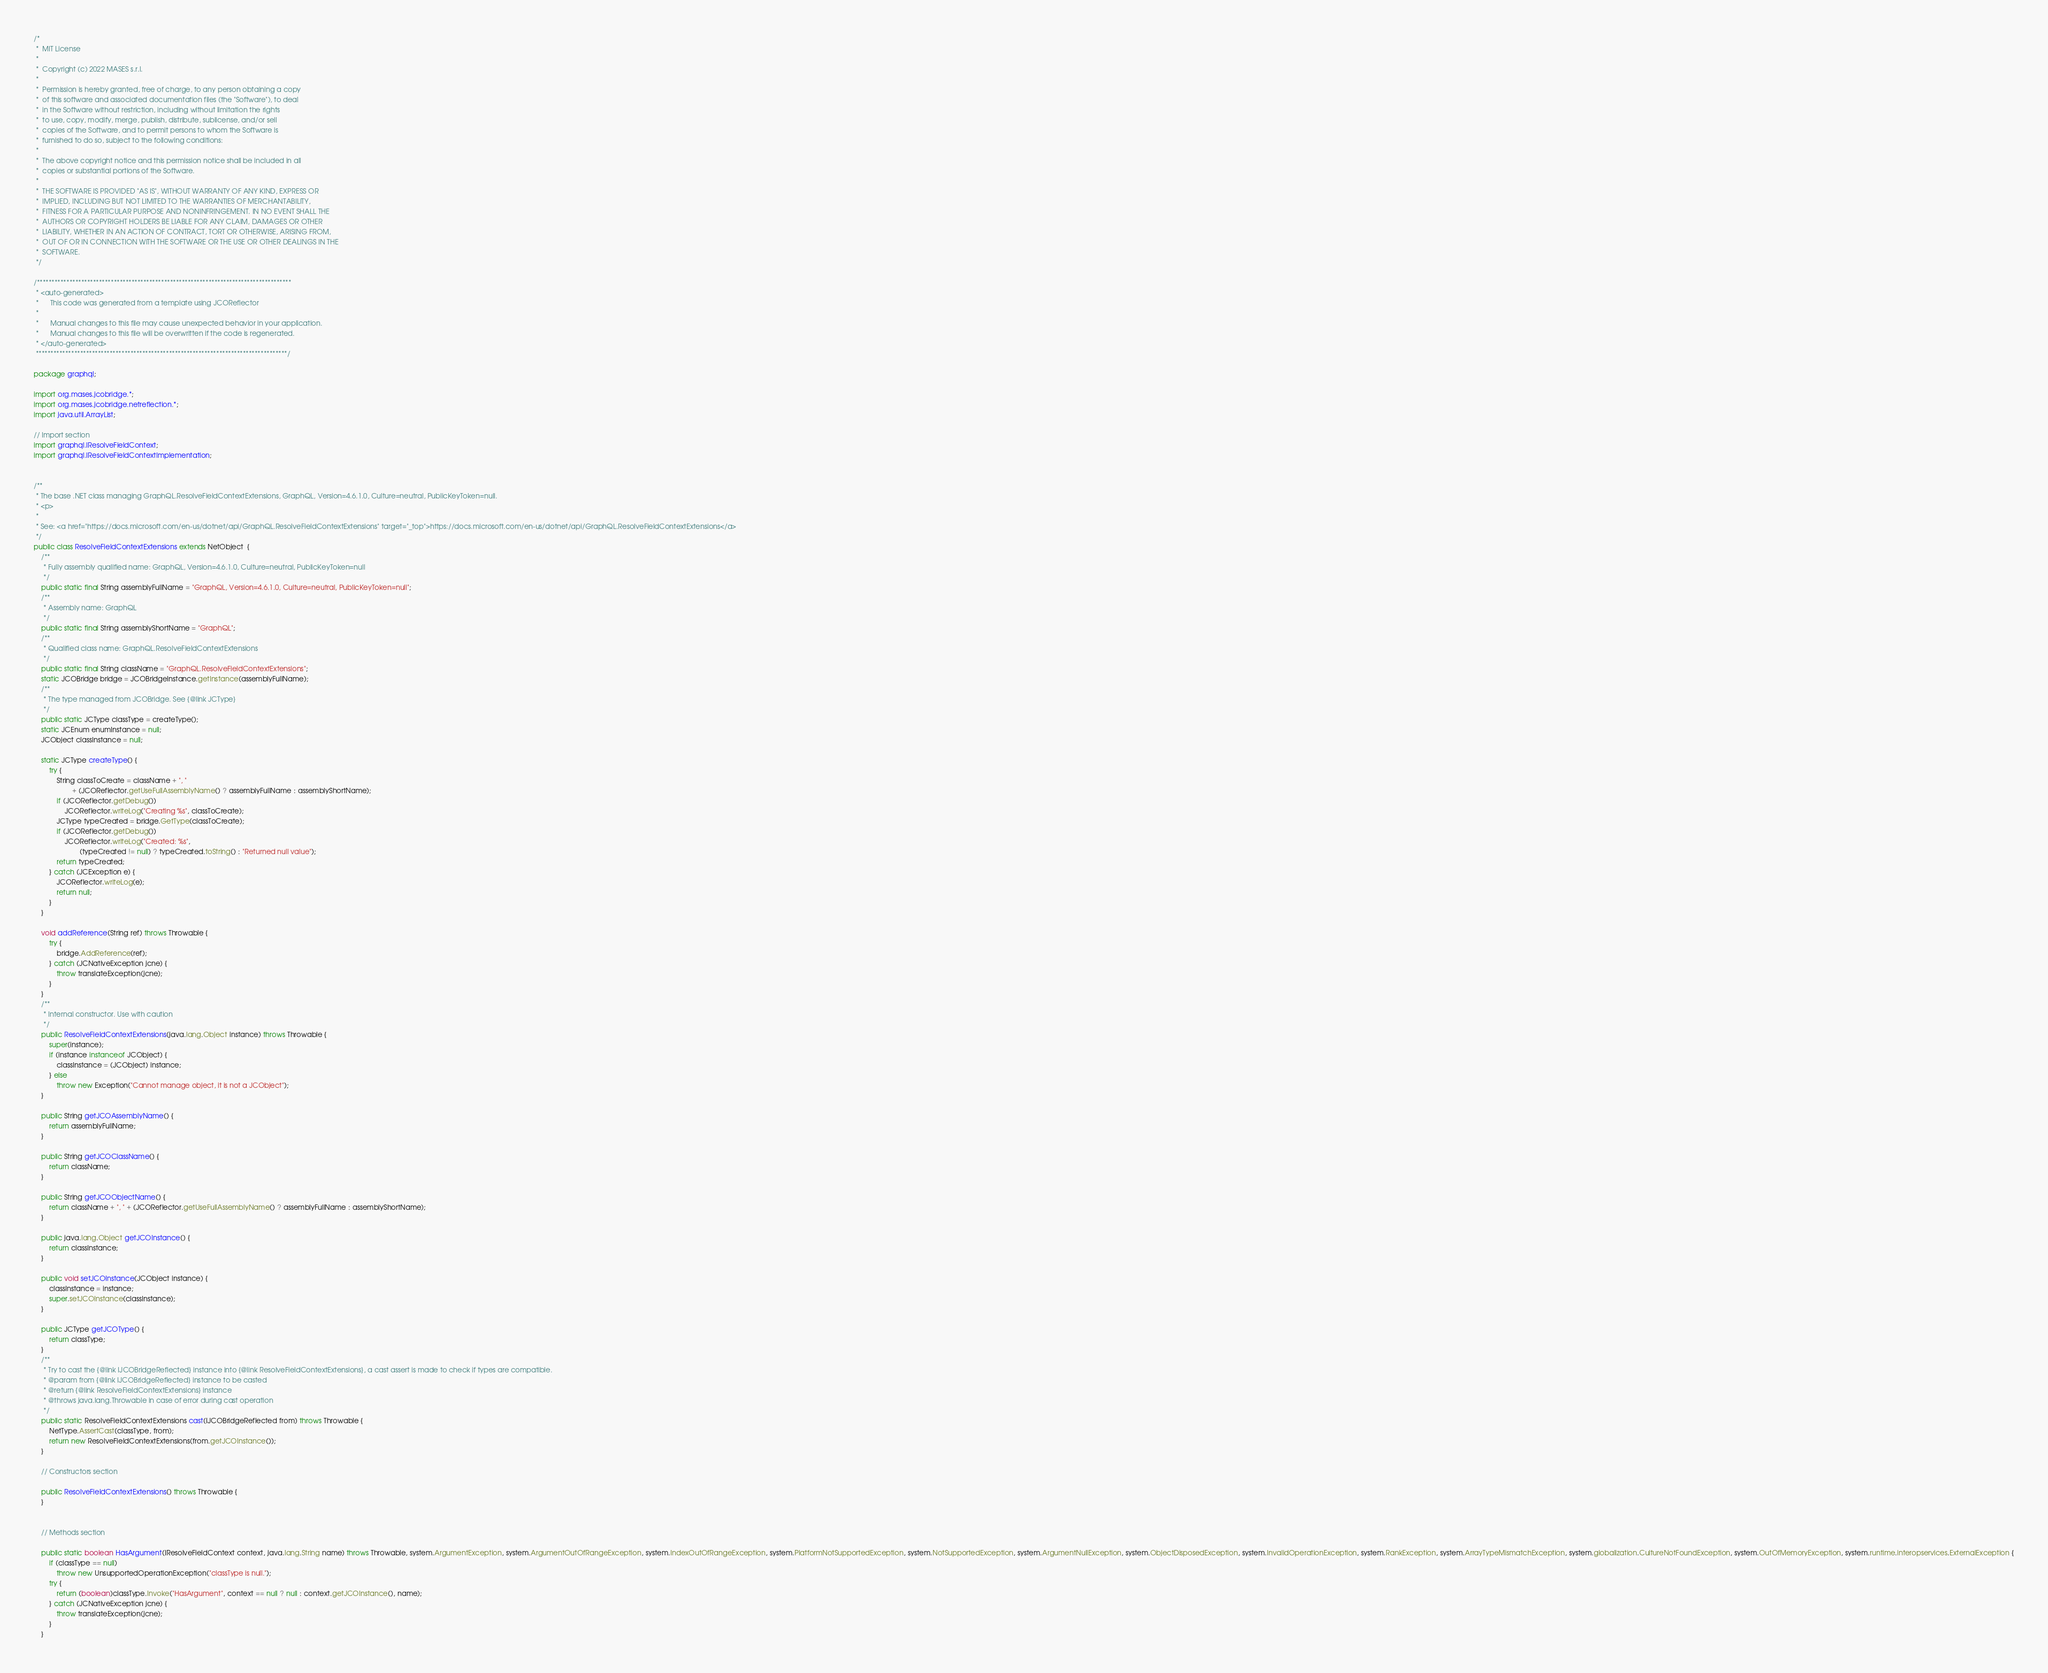Convert code to text. <code><loc_0><loc_0><loc_500><loc_500><_Java_>/*
 *  MIT License
 *
 *  Copyright (c) 2022 MASES s.r.l.
 *
 *  Permission is hereby granted, free of charge, to any person obtaining a copy
 *  of this software and associated documentation files (the "Software"), to deal
 *  in the Software without restriction, including without limitation the rights
 *  to use, copy, modify, merge, publish, distribute, sublicense, and/or sell
 *  copies of the Software, and to permit persons to whom the Software is
 *  furnished to do so, subject to the following conditions:
 *
 *  The above copyright notice and this permission notice shall be included in all
 *  copies or substantial portions of the Software.
 *
 *  THE SOFTWARE IS PROVIDED "AS IS", WITHOUT WARRANTY OF ANY KIND, EXPRESS OR
 *  IMPLIED, INCLUDING BUT NOT LIMITED TO THE WARRANTIES OF MERCHANTABILITY,
 *  FITNESS FOR A PARTICULAR PURPOSE AND NONINFRINGEMENT. IN NO EVENT SHALL THE
 *  AUTHORS OR COPYRIGHT HOLDERS BE LIABLE FOR ANY CLAIM, DAMAGES OR OTHER
 *  LIABILITY, WHETHER IN AN ACTION OF CONTRACT, TORT OR OTHERWISE, ARISING FROM,
 *  OUT OF OR IN CONNECTION WITH THE SOFTWARE OR THE USE OR OTHER DEALINGS IN THE
 *  SOFTWARE.
 */

/**************************************************************************************
 * <auto-generated>
 *      This code was generated from a template using JCOReflector
 * 
 *      Manual changes to this file may cause unexpected behavior in your application.
 *      Manual changes to this file will be overwritten if the code is regenerated.
 * </auto-generated>
 *************************************************************************************/

package graphql;

import org.mases.jcobridge.*;
import org.mases.jcobridge.netreflection.*;
import java.util.ArrayList;

// Import section
import graphql.IResolveFieldContext;
import graphql.IResolveFieldContextImplementation;


/**
 * The base .NET class managing GraphQL.ResolveFieldContextExtensions, GraphQL, Version=4.6.1.0, Culture=neutral, PublicKeyToken=null.
 * <p>
 * 
 * See: <a href="https://docs.microsoft.com/en-us/dotnet/api/GraphQL.ResolveFieldContextExtensions" target="_top">https://docs.microsoft.com/en-us/dotnet/api/GraphQL.ResolveFieldContextExtensions</a>
 */
public class ResolveFieldContextExtensions extends NetObject  {
    /**
     * Fully assembly qualified name: GraphQL, Version=4.6.1.0, Culture=neutral, PublicKeyToken=null
     */
    public static final String assemblyFullName = "GraphQL, Version=4.6.1.0, Culture=neutral, PublicKeyToken=null";
    /**
     * Assembly name: GraphQL
     */
    public static final String assemblyShortName = "GraphQL";
    /**
     * Qualified class name: GraphQL.ResolveFieldContextExtensions
     */
    public static final String className = "GraphQL.ResolveFieldContextExtensions";
    static JCOBridge bridge = JCOBridgeInstance.getInstance(assemblyFullName);
    /**
     * The type managed from JCOBridge. See {@link JCType}
     */
    public static JCType classType = createType();
    static JCEnum enumInstance = null;
    JCObject classInstance = null;

    static JCType createType() {
        try {
            String classToCreate = className + ", "
                    + (JCOReflector.getUseFullAssemblyName() ? assemblyFullName : assemblyShortName);
            if (JCOReflector.getDebug())
                JCOReflector.writeLog("Creating %s", classToCreate);
            JCType typeCreated = bridge.GetType(classToCreate);
            if (JCOReflector.getDebug())
                JCOReflector.writeLog("Created: %s",
                        (typeCreated != null) ? typeCreated.toString() : "Returned null value");
            return typeCreated;
        } catch (JCException e) {
            JCOReflector.writeLog(e);
            return null;
        }
    }

    void addReference(String ref) throws Throwable {
        try {
            bridge.AddReference(ref);
        } catch (JCNativeException jcne) {
            throw translateException(jcne);
        }
    }
    /**
     * Internal constructor. Use with caution 
     */
    public ResolveFieldContextExtensions(java.lang.Object instance) throws Throwable {
        super(instance);
        if (instance instanceof JCObject) {
            classInstance = (JCObject) instance;
        } else
            throw new Exception("Cannot manage object, it is not a JCObject");
    }

    public String getJCOAssemblyName() {
        return assemblyFullName;
    }

    public String getJCOClassName() {
        return className;
    }

    public String getJCOObjectName() {
        return className + ", " + (JCOReflector.getUseFullAssemblyName() ? assemblyFullName : assemblyShortName);
    }

    public java.lang.Object getJCOInstance() {
        return classInstance;
    }

    public void setJCOInstance(JCObject instance) {
        classInstance = instance;
        super.setJCOInstance(classInstance);
    }

    public JCType getJCOType() {
        return classType;
    }
    /**
     * Try to cast the {@link IJCOBridgeReflected} instance into {@link ResolveFieldContextExtensions}, a cast assert is made to check if types are compatible.
     * @param from {@link IJCOBridgeReflected} instance to be casted
     * @return {@link ResolveFieldContextExtensions} instance
     * @throws java.lang.Throwable in case of error during cast operation
     */
    public static ResolveFieldContextExtensions cast(IJCOBridgeReflected from) throws Throwable {
        NetType.AssertCast(classType, from);
        return new ResolveFieldContextExtensions(from.getJCOInstance());
    }

    // Constructors section
    
    public ResolveFieldContextExtensions() throws Throwable {
    }

    
    // Methods section
    
    public static boolean HasArgument(IResolveFieldContext context, java.lang.String name) throws Throwable, system.ArgumentException, system.ArgumentOutOfRangeException, system.IndexOutOfRangeException, system.PlatformNotSupportedException, system.NotSupportedException, system.ArgumentNullException, system.ObjectDisposedException, system.InvalidOperationException, system.RankException, system.ArrayTypeMismatchException, system.globalization.CultureNotFoundException, system.OutOfMemoryException, system.runtime.interopservices.ExternalException {
        if (classType == null)
            throw new UnsupportedOperationException("classType is null.");
        try {
            return (boolean)classType.Invoke("HasArgument", context == null ? null : context.getJCOInstance(), name);
        } catch (JCNativeException jcne) {
            throw translateException(jcne);
        }
    }
</code> 